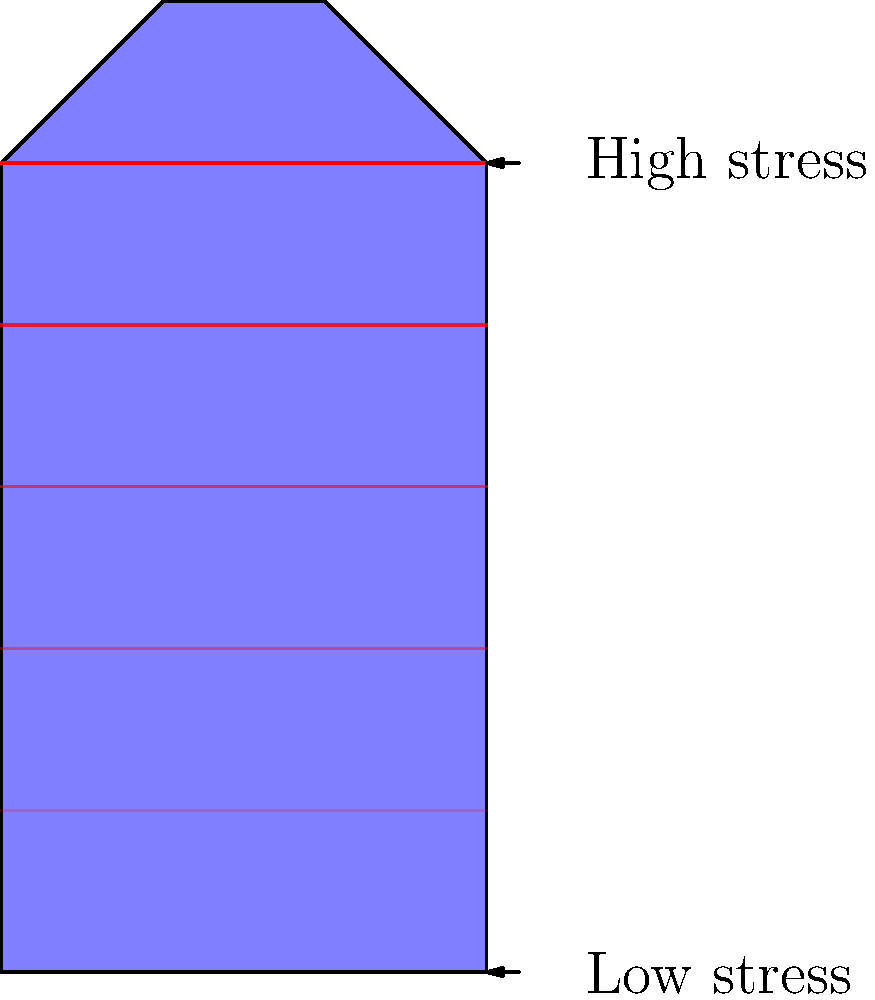A custom-designed reusable water bottle, perfect for your early morning hydration routine, has a unique shape as shown in the diagram. The stress distribution is indicated by the red lines, with darker shades representing higher stress. If the bottle is filled with your favorite innovative beverage, which area is likely to experience the highest stress concentration, and why? To determine the area of highest stress concentration, let's analyze the bottle's shape and the stress distribution:

1. Observe the bottle's geometry:
   - It has a wider top and bottom, with a narrower middle section.
   - There are sharp transitions between the wider and narrower parts.

2. Analyze the stress distribution:
   - The red lines represent stress, with darker shades indicating higher stress.
   - The stress appears to increase from bottom to top.

3. Consider stress concentration factors:
   - Stress concentrations often occur at geometric discontinuities or sharp changes in cross-section.
   - The transition from the wider top to the narrower middle section creates such a discontinuity.

4. Apply fluid mechanics principles:
   - When the bottle is filled, the fluid exerts hydrostatic pressure.
   - Pressure increases with depth, but the stress shown increases towards the top.

5. Combine the observations:
   - The highest stress (darkest red) is at the top of the bottle.
   - This coincides with the sharp transition in geometry.

6. Conclude:
   - The area of highest stress concentration is likely at the sharp transition between the wider top and narrower middle section.
   - This is due to the combination of geometric stress concentration and the indicated stress distribution.
Answer: The sharp transition between the wider top and narrower middle section. 